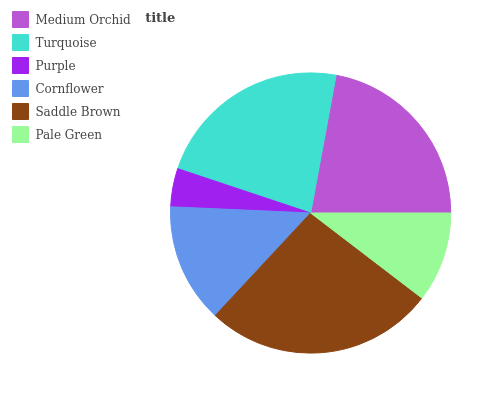Is Purple the minimum?
Answer yes or no. Yes. Is Saddle Brown the maximum?
Answer yes or no. Yes. Is Turquoise the minimum?
Answer yes or no. No. Is Turquoise the maximum?
Answer yes or no. No. Is Turquoise greater than Medium Orchid?
Answer yes or no. Yes. Is Medium Orchid less than Turquoise?
Answer yes or no. Yes. Is Medium Orchid greater than Turquoise?
Answer yes or no. No. Is Turquoise less than Medium Orchid?
Answer yes or no. No. Is Medium Orchid the high median?
Answer yes or no. Yes. Is Cornflower the low median?
Answer yes or no. Yes. Is Turquoise the high median?
Answer yes or no. No. Is Turquoise the low median?
Answer yes or no. No. 